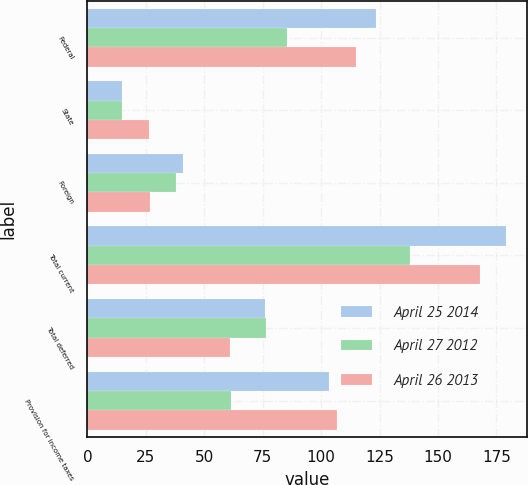Convert chart to OTSL. <chart><loc_0><loc_0><loc_500><loc_500><stacked_bar_chart><ecel><fcel>Federal<fcel>State<fcel>Foreign<fcel>Total current<fcel>Total deferred<fcel>Provision for income taxes<nl><fcel>April 25 2014<fcel>123.7<fcel>14.6<fcel>40.9<fcel>179.2<fcel>76<fcel>103.2<nl><fcel>April 27 2012<fcel>85.3<fcel>14.6<fcel>38<fcel>137.9<fcel>76.6<fcel>61.3<nl><fcel>April 26 2013<fcel>114.8<fcel>26.2<fcel>26.9<fcel>167.9<fcel>60.9<fcel>107<nl></chart> 